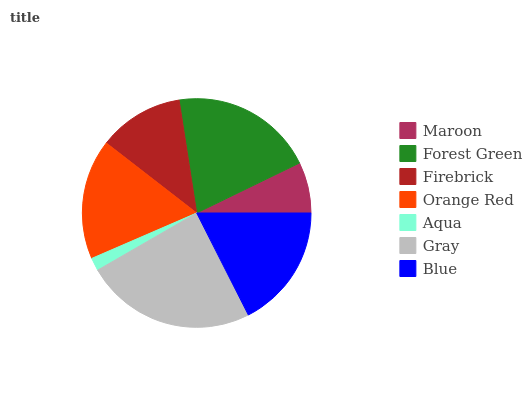Is Aqua the minimum?
Answer yes or no. Yes. Is Gray the maximum?
Answer yes or no. Yes. Is Forest Green the minimum?
Answer yes or no. No. Is Forest Green the maximum?
Answer yes or no. No. Is Forest Green greater than Maroon?
Answer yes or no. Yes. Is Maroon less than Forest Green?
Answer yes or no. Yes. Is Maroon greater than Forest Green?
Answer yes or no. No. Is Forest Green less than Maroon?
Answer yes or no. No. Is Orange Red the high median?
Answer yes or no. Yes. Is Orange Red the low median?
Answer yes or no. Yes. Is Aqua the high median?
Answer yes or no. No. Is Gray the low median?
Answer yes or no. No. 